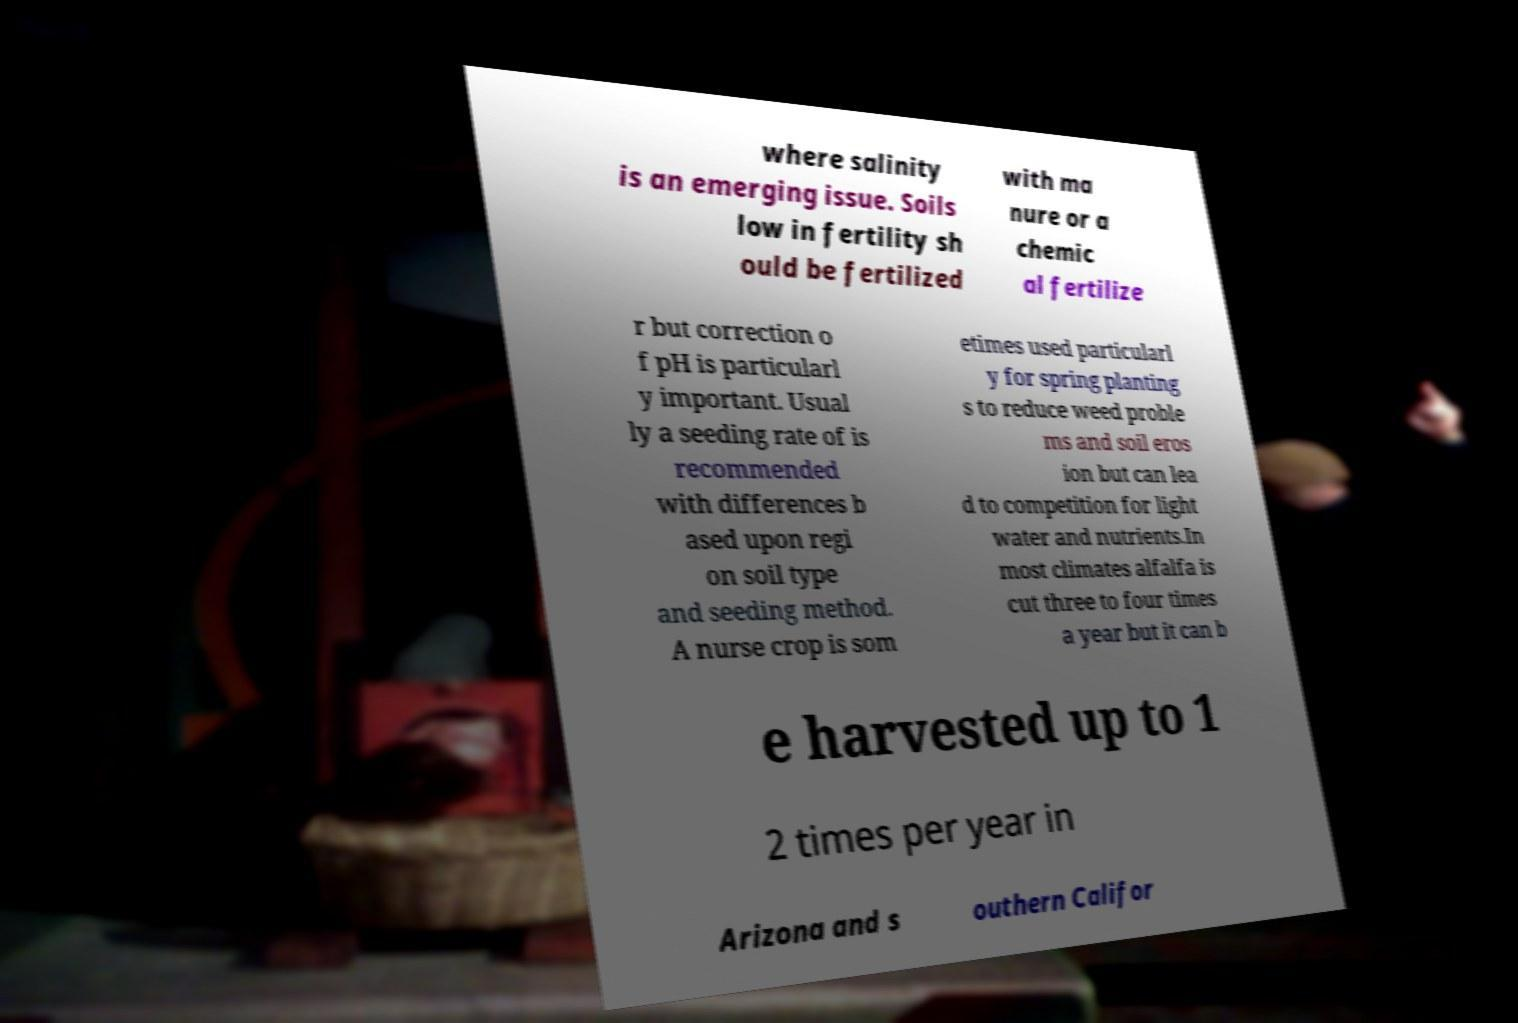Can you accurately transcribe the text from the provided image for me? where salinity is an emerging issue. Soils low in fertility sh ould be fertilized with ma nure or a chemic al fertilize r but correction o f pH is particularl y important. Usual ly a seeding rate of is recommended with differences b ased upon regi on soil type and seeding method. A nurse crop is som etimes used particularl y for spring planting s to reduce weed proble ms and soil eros ion but can lea d to competition for light water and nutrients.In most climates alfalfa is cut three to four times a year but it can b e harvested up to 1 2 times per year in Arizona and s outhern Califor 